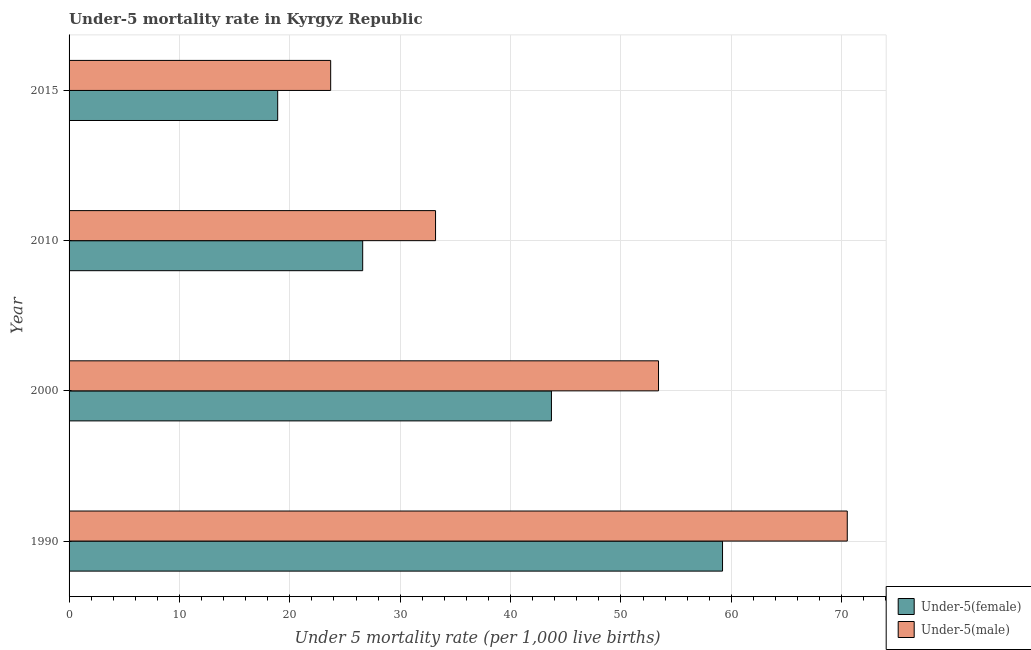How many bars are there on the 2nd tick from the bottom?
Provide a short and direct response. 2. Across all years, what is the maximum under-5 female mortality rate?
Offer a very short reply. 59.2. Across all years, what is the minimum under-5 female mortality rate?
Offer a very short reply. 18.9. In which year was the under-5 female mortality rate maximum?
Offer a very short reply. 1990. In which year was the under-5 female mortality rate minimum?
Provide a short and direct response. 2015. What is the total under-5 male mortality rate in the graph?
Give a very brief answer. 180.8. What is the difference between the under-5 male mortality rate in 2010 and the under-5 female mortality rate in 2000?
Offer a very short reply. -10.5. What is the average under-5 female mortality rate per year?
Make the answer very short. 37.1. In how many years, is the under-5 male mortality rate greater than 24 ?
Provide a short and direct response. 3. What is the ratio of the under-5 female mortality rate in 2000 to that in 2010?
Ensure brevity in your answer.  1.64. What is the difference between the highest and the second highest under-5 female mortality rate?
Give a very brief answer. 15.5. What is the difference between the highest and the lowest under-5 male mortality rate?
Offer a very short reply. 46.8. Is the sum of the under-5 male mortality rate in 1990 and 2000 greater than the maximum under-5 female mortality rate across all years?
Your response must be concise. Yes. What does the 2nd bar from the top in 2010 represents?
Offer a very short reply. Under-5(female). What does the 1st bar from the bottom in 2010 represents?
Your response must be concise. Under-5(female). Are all the bars in the graph horizontal?
Provide a short and direct response. Yes. How many years are there in the graph?
Offer a terse response. 4. What is the difference between two consecutive major ticks on the X-axis?
Keep it short and to the point. 10. Where does the legend appear in the graph?
Ensure brevity in your answer.  Bottom right. What is the title of the graph?
Provide a short and direct response. Under-5 mortality rate in Kyrgyz Republic. Does "Non-pregnant women" appear as one of the legend labels in the graph?
Keep it short and to the point. No. What is the label or title of the X-axis?
Offer a terse response. Under 5 mortality rate (per 1,0 live births). What is the label or title of the Y-axis?
Offer a very short reply. Year. What is the Under 5 mortality rate (per 1,000 live births) of Under-5(female) in 1990?
Your answer should be compact. 59.2. What is the Under 5 mortality rate (per 1,000 live births) in Under-5(male) in 1990?
Give a very brief answer. 70.5. What is the Under 5 mortality rate (per 1,000 live births) of Under-5(female) in 2000?
Offer a very short reply. 43.7. What is the Under 5 mortality rate (per 1,000 live births) of Under-5(male) in 2000?
Offer a very short reply. 53.4. What is the Under 5 mortality rate (per 1,000 live births) of Under-5(female) in 2010?
Offer a very short reply. 26.6. What is the Under 5 mortality rate (per 1,000 live births) in Under-5(male) in 2010?
Your answer should be compact. 33.2. What is the Under 5 mortality rate (per 1,000 live births) of Under-5(male) in 2015?
Your response must be concise. 23.7. Across all years, what is the maximum Under 5 mortality rate (per 1,000 live births) in Under-5(female)?
Offer a terse response. 59.2. Across all years, what is the maximum Under 5 mortality rate (per 1,000 live births) of Under-5(male)?
Your answer should be very brief. 70.5. Across all years, what is the minimum Under 5 mortality rate (per 1,000 live births) in Under-5(female)?
Offer a terse response. 18.9. Across all years, what is the minimum Under 5 mortality rate (per 1,000 live births) in Under-5(male)?
Your response must be concise. 23.7. What is the total Under 5 mortality rate (per 1,000 live births) in Under-5(female) in the graph?
Keep it short and to the point. 148.4. What is the total Under 5 mortality rate (per 1,000 live births) in Under-5(male) in the graph?
Provide a short and direct response. 180.8. What is the difference between the Under 5 mortality rate (per 1,000 live births) in Under-5(female) in 1990 and that in 2000?
Your answer should be very brief. 15.5. What is the difference between the Under 5 mortality rate (per 1,000 live births) of Under-5(female) in 1990 and that in 2010?
Provide a succinct answer. 32.6. What is the difference between the Under 5 mortality rate (per 1,000 live births) in Under-5(male) in 1990 and that in 2010?
Offer a very short reply. 37.3. What is the difference between the Under 5 mortality rate (per 1,000 live births) of Under-5(female) in 1990 and that in 2015?
Provide a succinct answer. 40.3. What is the difference between the Under 5 mortality rate (per 1,000 live births) in Under-5(male) in 1990 and that in 2015?
Ensure brevity in your answer.  46.8. What is the difference between the Under 5 mortality rate (per 1,000 live births) in Under-5(female) in 2000 and that in 2010?
Your answer should be compact. 17.1. What is the difference between the Under 5 mortality rate (per 1,000 live births) in Under-5(male) in 2000 and that in 2010?
Your response must be concise. 20.2. What is the difference between the Under 5 mortality rate (per 1,000 live births) in Under-5(female) in 2000 and that in 2015?
Offer a terse response. 24.8. What is the difference between the Under 5 mortality rate (per 1,000 live births) in Under-5(male) in 2000 and that in 2015?
Offer a very short reply. 29.7. What is the difference between the Under 5 mortality rate (per 1,000 live births) in Under-5(male) in 2010 and that in 2015?
Give a very brief answer. 9.5. What is the difference between the Under 5 mortality rate (per 1,000 live births) of Under-5(female) in 1990 and the Under 5 mortality rate (per 1,000 live births) of Under-5(male) in 2015?
Provide a short and direct response. 35.5. What is the difference between the Under 5 mortality rate (per 1,000 live births) in Under-5(female) in 2000 and the Under 5 mortality rate (per 1,000 live births) in Under-5(male) in 2010?
Offer a very short reply. 10.5. What is the difference between the Under 5 mortality rate (per 1,000 live births) in Under-5(female) in 2000 and the Under 5 mortality rate (per 1,000 live births) in Under-5(male) in 2015?
Your response must be concise. 20. What is the difference between the Under 5 mortality rate (per 1,000 live births) of Under-5(female) in 2010 and the Under 5 mortality rate (per 1,000 live births) of Under-5(male) in 2015?
Ensure brevity in your answer.  2.9. What is the average Under 5 mortality rate (per 1,000 live births) of Under-5(female) per year?
Offer a very short reply. 37.1. What is the average Under 5 mortality rate (per 1,000 live births) of Under-5(male) per year?
Keep it short and to the point. 45.2. In the year 2000, what is the difference between the Under 5 mortality rate (per 1,000 live births) of Under-5(female) and Under 5 mortality rate (per 1,000 live births) of Under-5(male)?
Your response must be concise. -9.7. In the year 2010, what is the difference between the Under 5 mortality rate (per 1,000 live births) in Under-5(female) and Under 5 mortality rate (per 1,000 live births) in Under-5(male)?
Make the answer very short. -6.6. In the year 2015, what is the difference between the Under 5 mortality rate (per 1,000 live births) of Under-5(female) and Under 5 mortality rate (per 1,000 live births) of Under-5(male)?
Keep it short and to the point. -4.8. What is the ratio of the Under 5 mortality rate (per 1,000 live births) of Under-5(female) in 1990 to that in 2000?
Offer a terse response. 1.35. What is the ratio of the Under 5 mortality rate (per 1,000 live births) of Under-5(male) in 1990 to that in 2000?
Provide a succinct answer. 1.32. What is the ratio of the Under 5 mortality rate (per 1,000 live births) of Under-5(female) in 1990 to that in 2010?
Your answer should be compact. 2.23. What is the ratio of the Under 5 mortality rate (per 1,000 live births) in Under-5(male) in 1990 to that in 2010?
Provide a short and direct response. 2.12. What is the ratio of the Under 5 mortality rate (per 1,000 live births) of Under-5(female) in 1990 to that in 2015?
Your response must be concise. 3.13. What is the ratio of the Under 5 mortality rate (per 1,000 live births) in Under-5(male) in 1990 to that in 2015?
Ensure brevity in your answer.  2.97. What is the ratio of the Under 5 mortality rate (per 1,000 live births) in Under-5(female) in 2000 to that in 2010?
Provide a succinct answer. 1.64. What is the ratio of the Under 5 mortality rate (per 1,000 live births) in Under-5(male) in 2000 to that in 2010?
Give a very brief answer. 1.61. What is the ratio of the Under 5 mortality rate (per 1,000 live births) of Under-5(female) in 2000 to that in 2015?
Keep it short and to the point. 2.31. What is the ratio of the Under 5 mortality rate (per 1,000 live births) of Under-5(male) in 2000 to that in 2015?
Offer a terse response. 2.25. What is the ratio of the Under 5 mortality rate (per 1,000 live births) in Under-5(female) in 2010 to that in 2015?
Make the answer very short. 1.41. What is the ratio of the Under 5 mortality rate (per 1,000 live births) in Under-5(male) in 2010 to that in 2015?
Offer a terse response. 1.4. What is the difference between the highest and the second highest Under 5 mortality rate (per 1,000 live births) in Under-5(female)?
Make the answer very short. 15.5. What is the difference between the highest and the lowest Under 5 mortality rate (per 1,000 live births) in Under-5(female)?
Give a very brief answer. 40.3. What is the difference between the highest and the lowest Under 5 mortality rate (per 1,000 live births) of Under-5(male)?
Give a very brief answer. 46.8. 